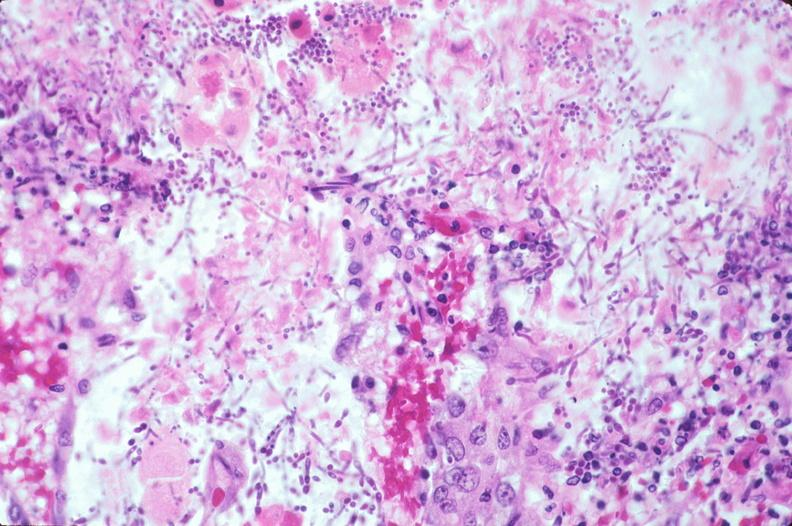what is present?
Answer the question using a single word or phrase. Gastrointestinal 